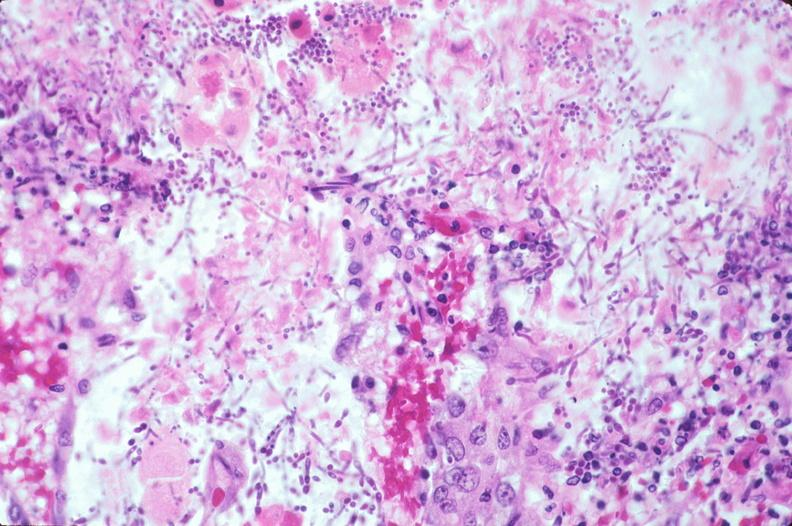what is present?
Answer the question using a single word or phrase. Gastrointestinal 